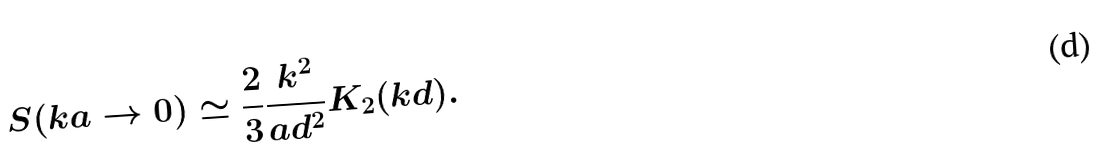<formula> <loc_0><loc_0><loc_500><loc_500>S ( k a \rightarrow 0 ) \simeq \frac { 2 } { 3 } \frac { k ^ { 2 } } { a d ^ { 2 } } K _ { 2 } ( k d ) .</formula> 